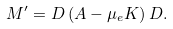<formula> <loc_0><loc_0><loc_500><loc_500>M ^ { \prime } = D \left ( A - \mu _ { e } K \right ) D .</formula> 